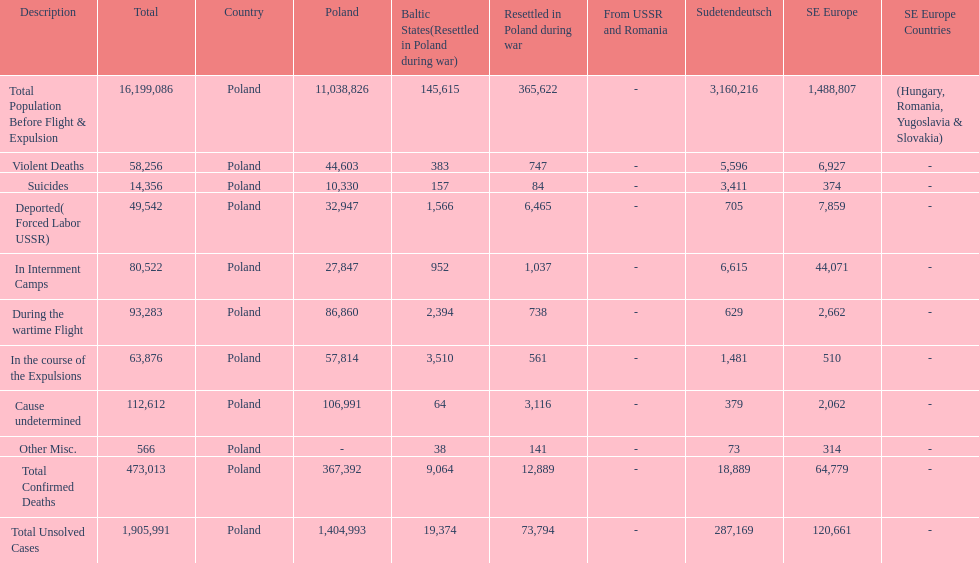Which region had the least total of unsolved cases? Baltic States(Resettled in Poland during war). 